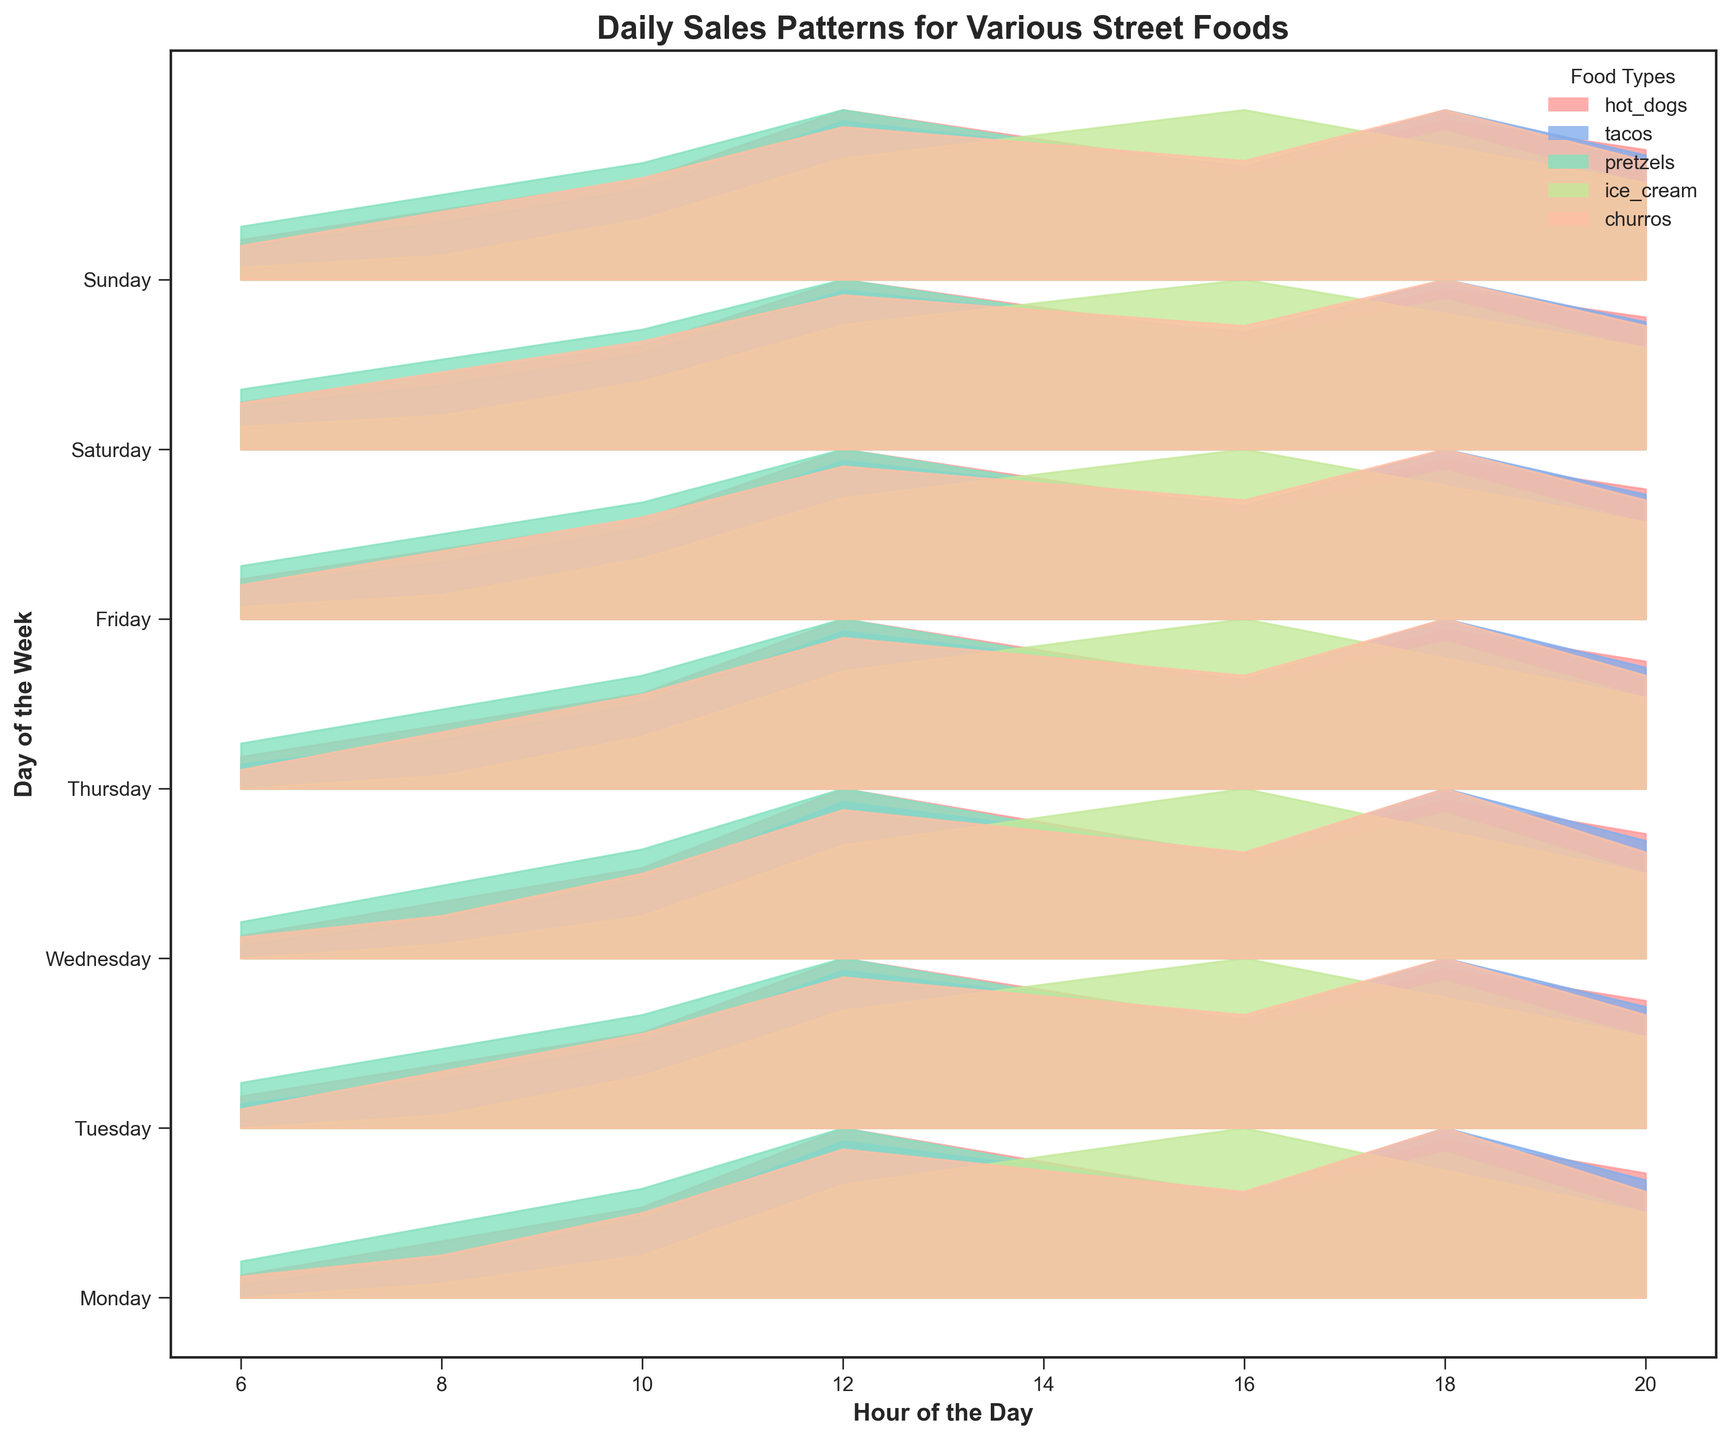What is the title of the figure? The title is usually found at the top of the figure. Here, it describes the plot's content.
Answer: Daily Sales Patterns for Various Street Foods What does the x-axis represent? The x-axis typically indicates an independent variable, which in this case, is labeled as "Hour of the Day".
Answer: Hour of the Day Which food type has the highest sales peak during 12 PM on Monday? Locate Monday on the y-axis, find the 12 PM line on the x-axis, and see which food has the highest peak at this hour. The highest peak is for "hot_dogs".
Answer: hot_dogs During which hour on Tuesday does ice cream sales peak? Locate Tuesday on the y-axis, identify the color representing ice cream (which is unique in the plot legend), and follow the curve to find its highest point, which is at 4 PM (16:00).
Answer: 4 PM Compare the sales of churros on Monday at 6 AM and 6 PM. Which hour had higher sales for churros on Monday? Locate Monday on the y-axis, find 6 AM and 6 PM on the x-axis, then compare the heights of the ridgeline for churros at these hours. 6 PM has a higher peak.
Answer: 6 PM On which day do hot_dogs and tacos both have their maximum sales at around 6 PM? Find the day when both hot_dogs and tacos have high peaks at 6 PM on the x-axis. It's Saturday.
Answer: Saturday What is the pattern of sales for pretzels throughout the week? Observe the lines of pretzel sales on each day from 6 AM to 8 PM and note general trends like peaks at noon, steady drops, or consistent sales. Typically, pretzels have noticeable peaks around noon each day.
Answer: Peaks around noon Which day shows the lowest sales of ice_cream at 12 PM? How can you tell? Scan the line representing 12 PM across all days and compare the peaks of ice_cream sales (using color). The lowest peak is on Tuesday.
Answer: Tuesday How do churros sales at 2 PM on Friday compare to pretzels sales at the same time? Find 2 PM on Friday and compare the heights of the ridgelines for churros and pretzels. Churros have a slightly higher peak than pretzels.
Answer: Churros are higher What general sales trend can be observed for street foods on weekends compared to weekdays? Compare the overall height and variability of the ridgelines for weekends (Saturday and Sunday) with weekdays to find general trends. Weekends show generally higher and more varied sales peaks.
Answer: Higher and more varied on weekends 